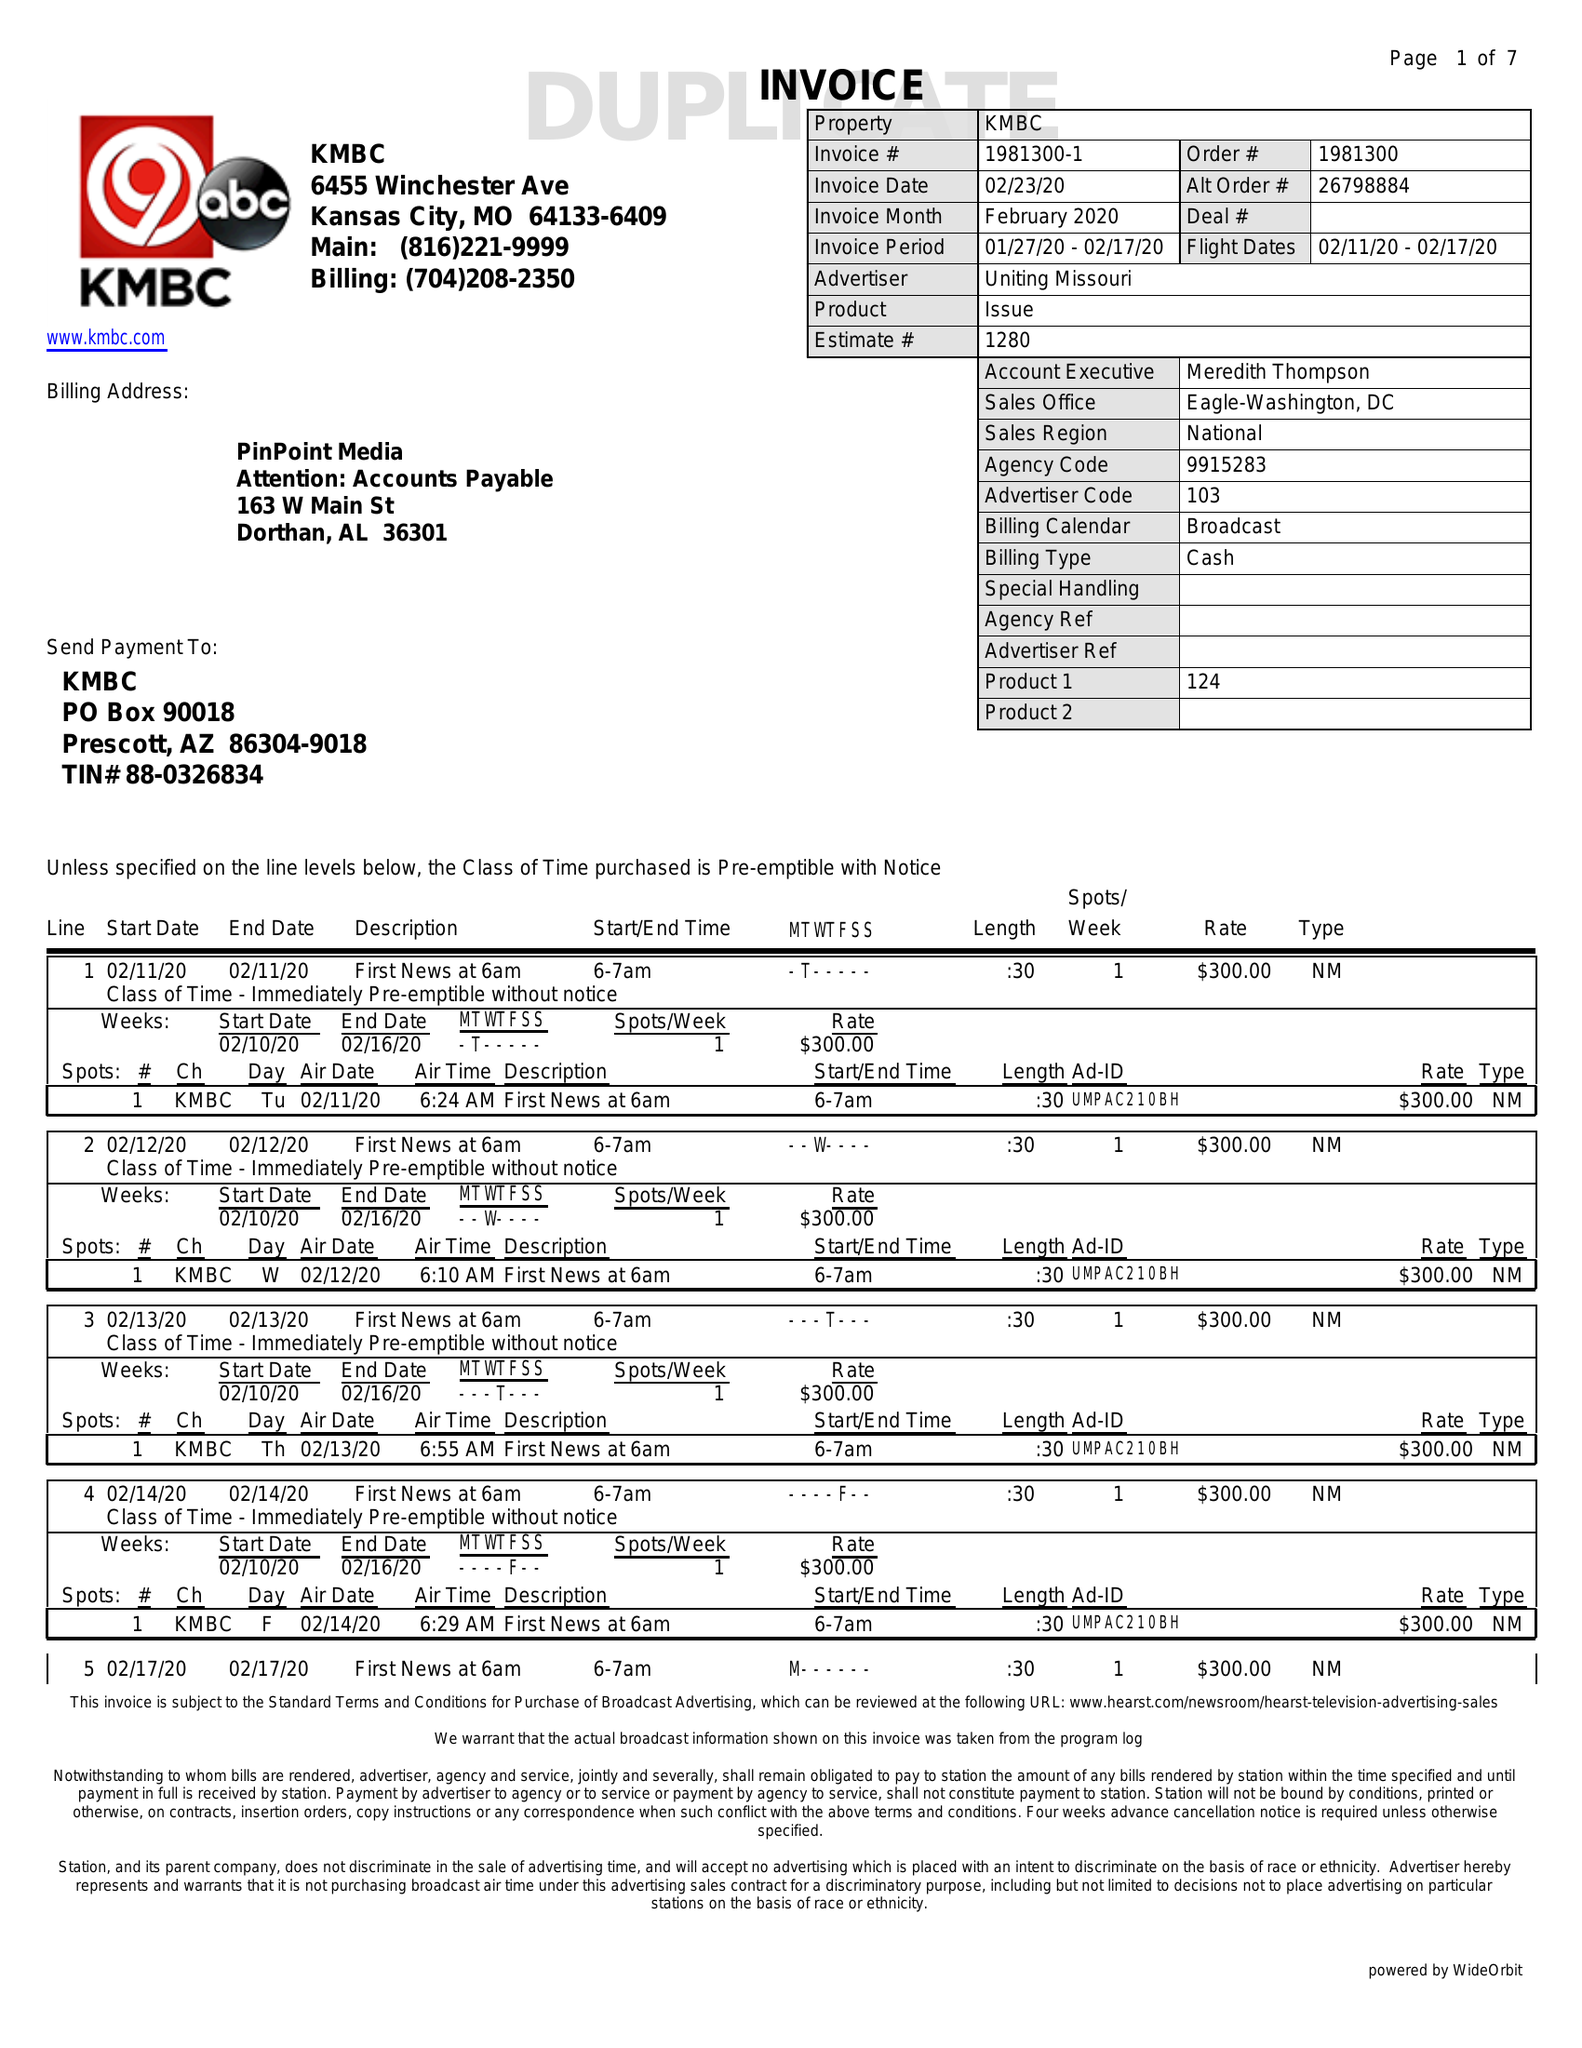What is the value for the flight_from?
Answer the question using a single word or phrase. 02/11/20 